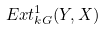<formula> <loc_0><loc_0><loc_500><loc_500>E x t _ { k G } ^ { 1 } ( Y , X )</formula> 